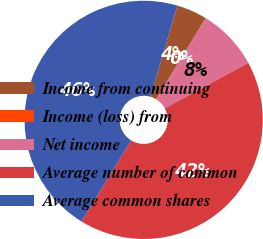Convert chart. <chart><loc_0><loc_0><loc_500><loc_500><pie_chart><fcel>Income from continuing<fcel>Income (loss) from<fcel>Net income<fcel>Average number of common<fcel>Average common shares<nl><fcel>4.17%<fcel>0.0%<fcel>8.33%<fcel>41.67%<fcel>45.83%<nl></chart> 